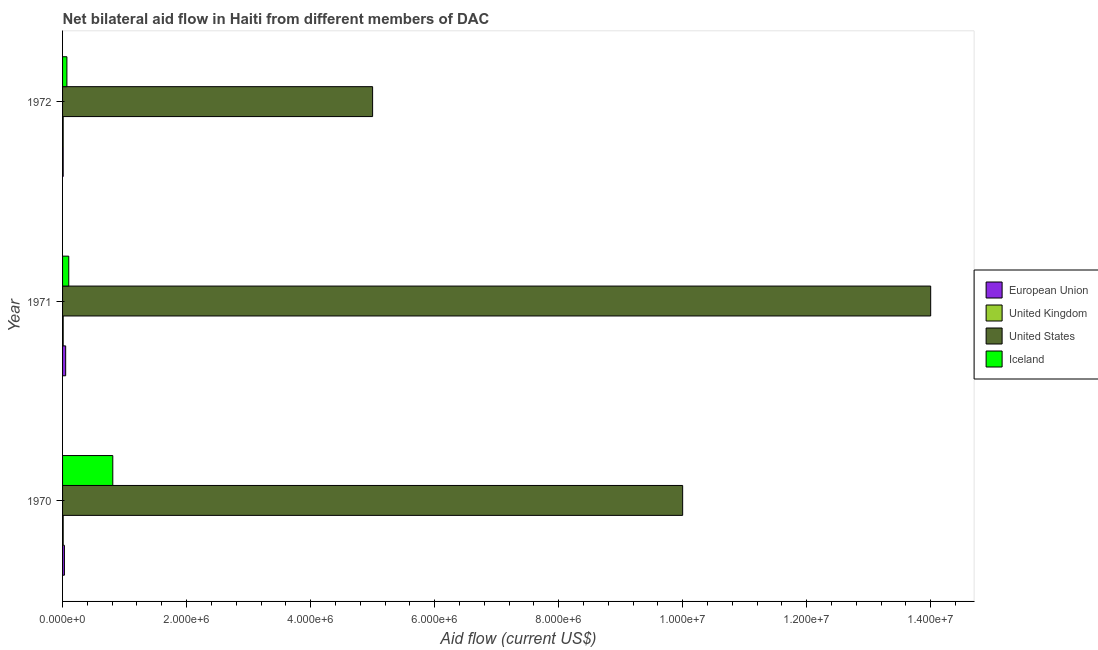How many groups of bars are there?
Offer a terse response. 3. Are the number of bars per tick equal to the number of legend labels?
Your answer should be compact. Yes. Are the number of bars on each tick of the Y-axis equal?
Keep it short and to the point. Yes. How many bars are there on the 1st tick from the top?
Ensure brevity in your answer.  4. How many bars are there on the 2nd tick from the bottom?
Make the answer very short. 4. In how many cases, is the number of bars for a given year not equal to the number of legend labels?
Ensure brevity in your answer.  0. What is the amount of aid given by uk in 1972?
Your response must be concise. 10000. Across all years, what is the maximum amount of aid given by eu?
Your answer should be very brief. 5.00e+04. Across all years, what is the minimum amount of aid given by iceland?
Give a very brief answer. 7.00e+04. In which year was the amount of aid given by uk maximum?
Ensure brevity in your answer.  1970. In which year was the amount of aid given by uk minimum?
Provide a short and direct response. 1970. What is the total amount of aid given by iceland in the graph?
Offer a terse response. 9.80e+05. What is the difference between the amount of aid given by uk in 1971 and that in 1972?
Provide a succinct answer. 0. What is the difference between the amount of aid given by eu in 1972 and the amount of aid given by iceland in 1971?
Offer a terse response. -9.00e+04. What is the average amount of aid given by iceland per year?
Your response must be concise. 3.27e+05. In the year 1971, what is the difference between the amount of aid given by uk and amount of aid given by iceland?
Provide a succinct answer. -9.00e+04. What is the ratio of the amount of aid given by iceland in 1970 to that in 1972?
Your answer should be very brief. 11.57. What is the difference between the highest and the lowest amount of aid given by iceland?
Ensure brevity in your answer.  7.40e+05. In how many years, is the amount of aid given by iceland greater than the average amount of aid given by iceland taken over all years?
Provide a short and direct response. 1. Is the sum of the amount of aid given by uk in 1971 and 1972 greater than the maximum amount of aid given by iceland across all years?
Offer a very short reply. No. What does the 4th bar from the top in 1970 represents?
Offer a very short reply. European Union. What does the 4th bar from the bottom in 1971 represents?
Make the answer very short. Iceland. Are all the bars in the graph horizontal?
Provide a succinct answer. Yes. Are the values on the major ticks of X-axis written in scientific E-notation?
Provide a short and direct response. Yes. Does the graph contain grids?
Ensure brevity in your answer.  No. Where does the legend appear in the graph?
Provide a short and direct response. Center right. How are the legend labels stacked?
Offer a very short reply. Vertical. What is the title of the graph?
Your answer should be very brief. Net bilateral aid flow in Haiti from different members of DAC. Does "Public sector management" appear as one of the legend labels in the graph?
Your answer should be compact. No. What is the label or title of the X-axis?
Ensure brevity in your answer.  Aid flow (current US$). What is the label or title of the Y-axis?
Your answer should be compact. Year. What is the Aid flow (current US$) in European Union in 1970?
Your answer should be very brief. 3.00e+04. What is the Aid flow (current US$) of Iceland in 1970?
Provide a succinct answer. 8.10e+05. What is the Aid flow (current US$) of United Kingdom in 1971?
Your answer should be compact. 10000. What is the Aid flow (current US$) in United States in 1971?
Your response must be concise. 1.40e+07. What is the Aid flow (current US$) of Iceland in 1971?
Offer a very short reply. 1.00e+05. What is the Aid flow (current US$) in United States in 1972?
Ensure brevity in your answer.  5.00e+06. What is the Aid flow (current US$) of Iceland in 1972?
Keep it short and to the point. 7.00e+04. Across all years, what is the maximum Aid flow (current US$) of European Union?
Your answer should be very brief. 5.00e+04. Across all years, what is the maximum Aid flow (current US$) in United Kingdom?
Give a very brief answer. 10000. Across all years, what is the maximum Aid flow (current US$) in United States?
Offer a very short reply. 1.40e+07. Across all years, what is the maximum Aid flow (current US$) of Iceland?
Ensure brevity in your answer.  8.10e+05. Across all years, what is the minimum Aid flow (current US$) of United States?
Offer a very short reply. 5.00e+06. What is the total Aid flow (current US$) of United Kingdom in the graph?
Provide a succinct answer. 3.00e+04. What is the total Aid flow (current US$) of United States in the graph?
Ensure brevity in your answer.  2.90e+07. What is the total Aid flow (current US$) in Iceland in the graph?
Provide a succinct answer. 9.80e+05. What is the difference between the Aid flow (current US$) in European Union in 1970 and that in 1971?
Ensure brevity in your answer.  -2.00e+04. What is the difference between the Aid flow (current US$) in United States in 1970 and that in 1971?
Offer a very short reply. -4.00e+06. What is the difference between the Aid flow (current US$) in Iceland in 1970 and that in 1971?
Provide a short and direct response. 7.10e+05. What is the difference between the Aid flow (current US$) of United Kingdom in 1970 and that in 1972?
Give a very brief answer. 0. What is the difference between the Aid flow (current US$) in United States in 1970 and that in 1972?
Your answer should be compact. 5.00e+06. What is the difference between the Aid flow (current US$) of Iceland in 1970 and that in 1972?
Provide a succinct answer. 7.40e+05. What is the difference between the Aid flow (current US$) of United States in 1971 and that in 1972?
Make the answer very short. 9.00e+06. What is the difference between the Aid flow (current US$) in European Union in 1970 and the Aid flow (current US$) in United Kingdom in 1971?
Provide a succinct answer. 2.00e+04. What is the difference between the Aid flow (current US$) of European Union in 1970 and the Aid flow (current US$) of United States in 1971?
Offer a very short reply. -1.40e+07. What is the difference between the Aid flow (current US$) in United Kingdom in 1970 and the Aid flow (current US$) in United States in 1971?
Give a very brief answer. -1.40e+07. What is the difference between the Aid flow (current US$) of United Kingdom in 1970 and the Aid flow (current US$) of Iceland in 1971?
Give a very brief answer. -9.00e+04. What is the difference between the Aid flow (current US$) in United States in 1970 and the Aid flow (current US$) in Iceland in 1971?
Your answer should be compact. 9.90e+06. What is the difference between the Aid flow (current US$) of European Union in 1970 and the Aid flow (current US$) of United Kingdom in 1972?
Your answer should be very brief. 2.00e+04. What is the difference between the Aid flow (current US$) of European Union in 1970 and the Aid flow (current US$) of United States in 1972?
Provide a succinct answer. -4.97e+06. What is the difference between the Aid flow (current US$) of European Union in 1970 and the Aid flow (current US$) of Iceland in 1972?
Your answer should be compact. -4.00e+04. What is the difference between the Aid flow (current US$) in United Kingdom in 1970 and the Aid flow (current US$) in United States in 1972?
Make the answer very short. -4.99e+06. What is the difference between the Aid flow (current US$) of United Kingdom in 1970 and the Aid flow (current US$) of Iceland in 1972?
Your answer should be compact. -6.00e+04. What is the difference between the Aid flow (current US$) of United States in 1970 and the Aid flow (current US$) of Iceland in 1972?
Your answer should be very brief. 9.93e+06. What is the difference between the Aid flow (current US$) of European Union in 1971 and the Aid flow (current US$) of United States in 1972?
Your response must be concise. -4.95e+06. What is the difference between the Aid flow (current US$) in United Kingdom in 1971 and the Aid flow (current US$) in United States in 1972?
Offer a very short reply. -4.99e+06. What is the difference between the Aid flow (current US$) of United Kingdom in 1971 and the Aid flow (current US$) of Iceland in 1972?
Provide a succinct answer. -6.00e+04. What is the difference between the Aid flow (current US$) of United States in 1971 and the Aid flow (current US$) of Iceland in 1972?
Your answer should be very brief. 1.39e+07. What is the average Aid flow (current US$) of United States per year?
Ensure brevity in your answer.  9.67e+06. What is the average Aid flow (current US$) of Iceland per year?
Your response must be concise. 3.27e+05. In the year 1970, what is the difference between the Aid flow (current US$) in European Union and Aid flow (current US$) in United Kingdom?
Offer a terse response. 2.00e+04. In the year 1970, what is the difference between the Aid flow (current US$) of European Union and Aid flow (current US$) of United States?
Your response must be concise. -9.97e+06. In the year 1970, what is the difference between the Aid flow (current US$) of European Union and Aid flow (current US$) of Iceland?
Make the answer very short. -7.80e+05. In the year 1970, what is the difference between the Aid flow (current US$) in United Kingdom and Aid flow (current US$) in United States?
Your answer should be very brief. -9.99e+06. In the year 1970, what is the difference between the Aid flow (current US$) in United Kingdom and Aid flow (current US$) in Iceland?
Provide a succinct answer. -8.00e+05. In the year 1970, what is the difference between the Aid flow (current US$) in United States and Aid flow (current US$) in Iceland?
Your answer should be compact. 9.19e+06. In the year 1971, what is the difference between the Aid flow (current US$) in European Union and Aid flow (current US$) in United States?
Give a very brief answer. -1.40e+07. In the year 1971, what is the difference between the Aid flow (current US$) of European Union and Aid flow (current US$) of Iceland?
Offer a very short reply. -5.00e+04. In the year 1971, what is the difference between the Aid flow (current US$) of United Kingdom and Aid flow (current US$) of United States?
Offer a very short reply. -1.40e+07. In the year 1971, what is the difference between the Aid flow (current US$) in United States and Aid flow (current US$) in Iceland?
Your answer should be very brief. 1.39e+07. In the year 1972, what is the difference between the Aid flow (current US$) of European Union and Aid flow (current US$) of United Kingdom?
Keep it short and to the point. 0. In the year 1972, what is the difference between the Aid flow (current US$) in European Union and Aid flow (current US$) in United States?
Offer a very short reply. -4.99e+06. In the year 1972, what is the difference between the Aid flow (current US$) in European Union and Aid flow (current US$) in Iceland?
Offer a terse response. -6.00e+04. In the year 1972, what is the difference between the Aid flow (current US$) in United Kingdom and Aid flow (current US$) in United States?
Your response must be concise. -4.99e+06. In the year 1972, what is the difference between the Aid flow (current US$) of United Kingdom and Aid flow (current US$) of Iceland?
Offer a very short reply. -6.00e+04. In the year 1972, what is the difference between the Aid flow (current US$) of United States and Aid flow (current US$) of Iceland?
Make the answer very short. 4.93e+06. What is the ratio of the Aid flow (current US$) in United Kingdom in 1970 to that in 1971?
Give a very brief answer. 1. What is the ratio of the Aid flow (current US$) in United States in 1970 to that in 1971?
Provide a succinct answer. 0.71. What is the ratio of the Aid flow (current US$) in European Union in 1970 to that in 1972?
Provide a short and direct response. 3. What is the ratio of the Aid flow (current US$) of United Kingdom in 1970 to that in 1972?
Provide a short and direct response. 1. What is the ratio of the Aid flow (current US$) of Iceland in 1970 to that in 1972?
Provide a short and direct response. 11.57. What is the ratio of the Aid flow (current US$) in European Union in 1971 to that in 1972?
Keep it short and to the point. 5. What is the ratio of the Aid flow (current US$) in United Kingdom in 1971 to that in 1972?
Your answer should be compact. 1. What is the ratio of the Aid flow (current US$) in Iceland in 1971 to that in 1972?
Give a very brief answer. 1.43. What is the difference between the highest and the second highest Aid flow (current US$) in United Kingdom?
Provide a short and direct response. 0. What is the difference between the highest and the second highest Aid flow (current US$) of United States?
Give a very brief answer. 4.00e+06. What is the difference between the highest and the second highest Aid flow (current US$) of Iceland?
Your response must be concise. 7.10e+05. What is the difference between the highest and the lowest Aid flow (current US$) in United States?
Offer a terse response. 9.00e+06. What is the difference between the highest and the lowest Aid flow (current US$) of Iceland?
Your response must be concise. 7.40e+05. 